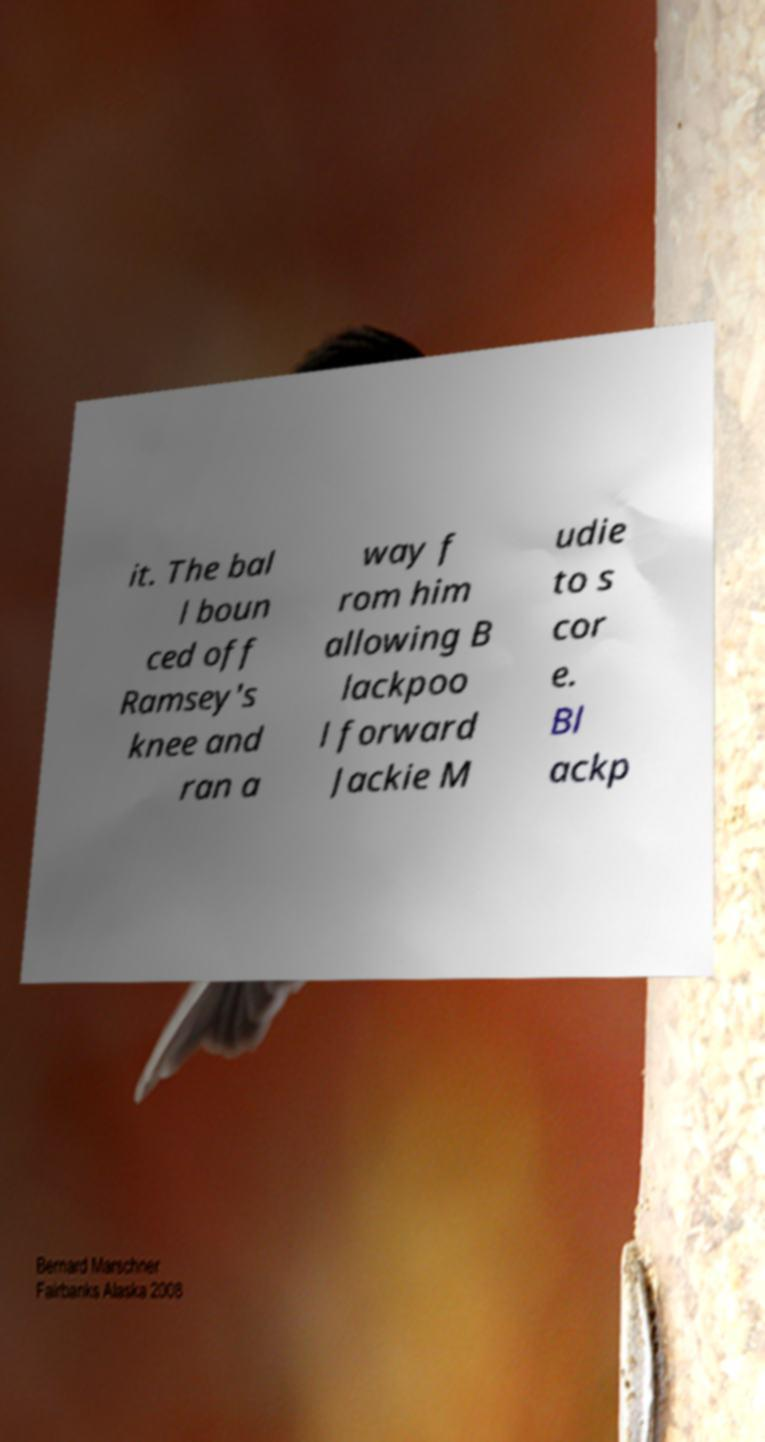Please read and relay the text visible in this image. What does it say? it. The bal l boun ced off Ramsey's knee and ran a way f rom him allowing B lackpoo l forward Jackie M udie to s cor e. Bl ackp 